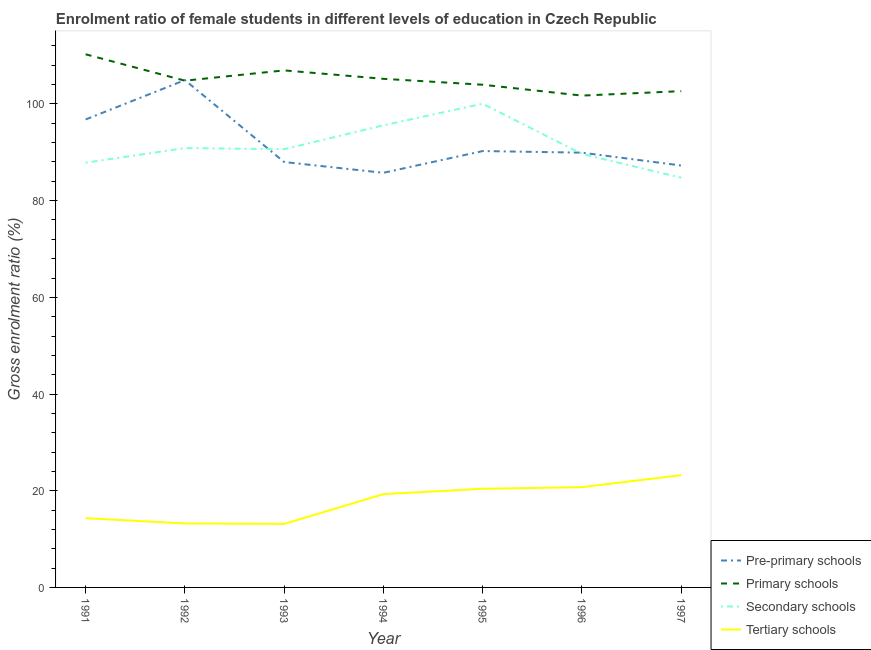How many different coloured lines are there?
Provide a short and direct response. 4. Does the line corresponding to gross enrolment ratio(male) in pre-primary schools intersect with the line corresponding to gross enrolment ratio(male) in tertiary schools?
Provide a succinct answer. No. What is the gross enrolment ratio(male) in primary schools in 1996?
Ensure brevity in your answer.  101.73. Across all years, what is the maximum gross enrolment ratio(male) in pre-primary schools?
Provide a short and direct response. 104.93. Across all years, what is the minimum gross enrolment ratio(male) in secondary schools?
Your answer should be very brief. 84.74. In which year was the gross enrolment ratio(male) in primary schools maximum?
Your answer should be very brief. 1991. What is the total gross enrolment ratio(male) in secondary schools in the graph?
Your answer should be compact. 639.41. What is the difference between the gross enrolment ratio(male) in tertiary schools in 1992 and that in 1993?
Give a very brief answer. 0.1. What is the difference between the gross enrolment ratio(male) in tertiary schools in 1993 and the gross enrolment ratio(male) in primary schools in 1997?
Give a very brief answer. -89.51. What is the average gross enrolment ratio(male) in pre-primary schools per year?
Give a very brief answer. 91.85. In the year 1997, what is the difference between the gross enrolment ratio(male) in primary schools and gross enrolment ratio(male) in tertiary schools?
Offer a very short reply. 79.44. In how many years, is the gross enrolment ratio(male) in primary schools greater than 4 %?
Ensure brevity in your answer.  7. What is the ratio of the gross enrolment ratio(male) in secondary schools in 1991 to that in 1994?
Provide a succinct answer. 0.92. Is the gross enrolment ratio(male) in secondary schools in 1991 less than that in 1997?
Your response must be concise. No. Is the difference between the gross enrolment ratio(male) in primary schools in 1992 and 1994 greater than the difference between the gross enrolment ratio(male) in pre-primary schools in 1992 and 1994?
Your answer should be compact. No. What is the difference between the highest and the second highest gross enrolment ratio(male) in tertiary schools?
Keep it short and to the point. 2.47. What is the difference between the highest and the lowest gross enrolment ratio(male) in primary schools?
Offer a very short reply. 8.54. In how many years, is the gross enrolment ratio(male) in tertiary schools greater than the average gross enrolment ratio(male) in tertiary schools taken over all years?
Give a very brief answer. 4. Is the sum of the gross enrolment ratio(male) in tertiary schools in 1992 and 1994 greater than the maximum gross enrolment ratio(male) in pre-primary schools across all years?
Provide a short and direct response. No. Is it the case that in every year, the sum of the gross enrolment ratio(male) in pre-primary schools and gross enrolment ratio(male) in primary schools is greater than the sum of gross enrolment ratio(male) in secondary schools and gross enrolment ratio(male) in tertiary schools?
Your answer should be compact. No. Is it the case that in every year, the sum of the gross enrolment ratio(male) in pre-primary schools and gross enrolment ratio(male) in primary schools is greater than the gross enrolment ratio(male) in secondary schools?
Offer a very short reply. Yes. Is the gross enrolment ratio(male) in pre-primary schools strictly greater than the gross enrolment ratio(male) in primary schools over the years?
Keep it short and to the point. No. Is the gross enrolment ratio(male) in primary schools strictly less than the gross enrolment ratio(male) in pre-primary schools over the years?
Provide a short and direct response. No. How many years are there in the graph?
Keep it short and to the point. 7. What is the difference between two consecutive major ticks on the Y-axis?
Provide a short and direct response. 20. Are the values on the major ticks of Y-axis written in scientific E-notation?
Give a very brief answer. No. Does the graph contain any zero values?
Your answer should be very brief. No. Does the graph contain grids?
Offer a very short reply. No. Where does the legend appear in the graph?
Make the answer very short. Bottom right. How are the legend labels stacked?
Your answer should be compact. Vertical. What is the title of the graph?
Provide a short and direct response. Enrolment ratio of female students in different levels of education in Czech Republic. Does "Gender equality" appear as one of the legend labels in the graph?
Ensure brevity in your answer.  No. What is the label or title of the X-axis?
Offer a very short reply. Year. What is the label or title of the Y-axis?
Your answer should be compact. Gross enrolment ratio (%). What is the Gross enrolment ratio (%) in Pre-primary schools in 1991?
Provide a short and direct response. 96.79. What is the Gross enrolment ratio (%) of Primary schools in 1991?
Ensure brevity in your answer.  110.27. What is the Gross enrolment ratio (%) of Secondary schools in 1991?
Offer a very short reply. 87.86. What is the Gross enrolment ratio (%) of Tertiary schools in 1991?
Your answer should be compact. 14.32. What is the Gross enrolment ratio (%) of Pre-primary schools in 1992?
Provide a succinct answer. 104.93. What is the Gross enrolment ratio (%) of Primary schools in 1992?
Ensure brevity in your answer.  104.82. What is the Gross enrolment ratio (%) of Secondary schools in 1992?
Offer a very short reply. 90.87. What is the Gross enrolment ratio (%) of Tertiary schools in 1992?
Your answer should be compact. 13.24. What is the Gross enrolment ratio (%) in Pre-primary schools in 1993?
Keep it short and to the point. 87.99. What is the Gross enrolment ratio (%) of Primary schools in 1993?
Your response must be concise. 106.94. What is the Gross enrolment ratio (%) in Secondary schools in 1993?
Offer a very short reply. 90.64. What is the Gross enrolment ratio (%) in Tertiary schools in 1993?
Give a very brief answer. 13.14. What is the Gross enrolment ratio (%) in Pre-primary schools in 1994?
Make the answer very short. 85.76. What is the Gross enrolment ratio (%) of Primary schools in 1994?
Keep it short and to the point. 105.2. What is the Gross enrolment ratio (%) in Secondary schools in 1994?
Give a very brief answer. 95.59. What is the Gross enrolment ratio (%) of Tertiary schools in 1994?
Your answer should be compact. 19.3. What is the Gross enrolment ratio (%) in Pre-primary schools in 1995?
Ensure brevity in your answer.  90.26. What is the Gross enrolment ratio (%) in Primary schools in 1995?
Give a very brief answer. 103.98. What is the Gross enrolment ratio (%) in Secondary schools in 1995?
Your response must be concise. 100.05. What is the Gross enrolment ratio (%) of Tertiary schools in 1995?
Give a very brief answer. 20.4. What is the Gross enrolment ratio (%) of Pre-primary schools in 1996?
Your response must be concise. 89.93. What is the Gross enrolment ratio (%) of Primary schools in 1996?
Your answer should be very brief. 101.73. What is the Gross enrolment ratio (%) in Secondary schools in 1996?
Your response must be concise. 89.66. What is the Gross enrolment ratio (%) of Tertiary schools in 1996?
Keep it short and to the point. 20.74. What is the Gross enrolment ratio (%) in Pre-primary schools in 1997?
Keep it short and to the point. 87.26. What is the Gross enrolment ratio (%) in Primary schools in 1997?
Provide a short and direct response. 102.65. What is the Gross enrolment ratio (%) in Secondary schools in 1997?
Your answer should be very brief. 84.74. What is the Gross enrolment ratio (%) of Tertiary schools in 1997?
Your response must be concise. 23.22. Across all years, what is the maximum Gross enrolment ratio (%) of Pre-primary schools?
Provide a short and direct response. 104.93. Across all years, what is the maximum Gross enrolment ratio (%) in Primary schools?
Your answer should be compact. 110.27. Across all years, what is the maximum Gross enrolment ratio (%) in Secondary schools?
Offer a very short reply. 100.05. Across all years, what is the maximum Gross enrolment ratio (%) of Tertiary schools?
Provide a short and direct response. 23.22. Across all years, what is the minimum Gross enrolment ratio (%) in Pre-primary schools?
Your answer should be very brief. 85.76. Across all years, what is the minimum Gross enrolment ratio (%) of Primary schools?
Ensure brevity in your answer.  101.73. Across all years, what is the minimum Gross enrolment ratio (%) in Secondary schools?
Offer a terse response. 84.74. Across all years, what is the minimum Gross enrolment ratio (%) in Tertiary schools?
Make the answer very short. 13.14. What is the total Gross enrolment ratio (%) of Pre-primary schools in the graph?
Your answer should be compact. 642.93. What is the total Gross enrolment ratio (%) in Primary schools in the graph?
Provide a short and direct response. 735.59. What is the total Gross enrolment ratio (%) in Secondary schools in the graph?
Keep it short and to the point. 639.41. What is the total Gross enrolment ratio (%) of Tertiary schools in the graph?
Ensure brevity in your answer.  124.35. What is the difference between the Gross enrolment ratio (%) in Pre-primary schools in 1991 and that in 1992?
Your answer should be very brief. -8.14. What is the difference between the Gross enrolment ratio (%) of Primary schools in 1991 and that in 1992?
Provide a short and direct response. 5.45. What is the difference between the Gross enrolment ratio (%) of Secondary schools in 1991 and that in 1992?
Offer a very short reply. -3.02. What is the difference between the Gross enrolment ratio (%) of Tertiary schools in 1991 and that in 1992?
Make the answer very short. 1.08. What is the difference between the Gross enrolment ratio (%) in Pre-primary schools in 1991 and that in 1993?
Offer a very short reply. 8.81. What is the difference between the Gross enrolment ratio (%) of Primary schools in 1991 and that in 1993?
Make the answer very short. 3.33. What is the difference between the Gross enrolment ratio (%) of Secondary schools in 1991 and that in 1993?
Offer a terse response. -2.79. What is the difference between the Gross enrolment ratio (%) of Tertiary schools in 1991 and that in 1993?
Offer a very short reply. 1.18. What is the difference between the Gross enrolment ratio (%) in Pre-primary schools in 1991 and that in 1994?
Your response must be concise. 11.03. What is the difference between the Gross enrolment ratio (%) of Primary schools in 1991 and that in 1994?
Ensure brevity in your answer.  5.07. What is the difference between the Gross enrolment ratio (%) in Secondary schools in 1991 and that in 1994?
Provide a succinct answer. -7.73. What is the difference between the Gross enrolment ratio (%) in Tertiary schools in 1991 and that in 1994?
Offer a very short reply. -4.98. What is the difference between the Gross enrolment ratio (%) in Pre-primary schools in 1991 and that in 1995?
Keep it short and to the point. 6.53. What is the difference between the Gross enrolment ratio (%) in Primary schools in 1991 and that in 1995?
Provide a short and direct response. 6.3. What is the difference between the Gross enrolment ratio (%) in Secondary schools in 1991 and that in 1995?
Your answer should be compact. -12.19. What is the difference between the Gross enrolment ratio (%) of Tertiary schools in 1991 and that in 1995?
Make the answer very short. -6.08. What is the difference between the Gross enrolment ratio (%) of Pre-primary schools in 1991 and that in 1996?
Your answer should be very brief. 6.87. What is the difference between the Gross enrolment ratio (%) in Primary schools in 1991 and that in 1996?
Your response must be concise. 8.54. What is the difference between the Gross enrolment ratio (%) in Secondary schools in 1991 and that in 1996?
Ensure brevity in your answer.  -1.81. What is the difference between the Gross enrolment ratio (%) of Tertiary schools in 1991 and that in 1996?
Ensure brevity in your answer.  -6.42. What is the difference between the Gross enrolment ratio (%) in Pre-primary schools in 1991 and that in 1997?
Provide a succinct answer. 9.53. What is the difference between the Gross enrolment ratio (%) of Primary schools in 1991 and that in 1997?
Make the answer very short. 7.62. What is the difference between the Gross enrolment ratio (%) in Secondary schools in 1991 and that in 1997?
Make the answer very short. 3.11. What is the difference between the Gross enrolment ratio (%) in Tertiary schools in 1991 and that in 1997?
Make the answer very short. -8.9. What is the difference between the Gross enrolment ratio (%) in Pre-primary schools in 1992 and that in 1993?
Keep it short and to the point. 16.95. What is the difference between the Gross enrolment ratio (%) of Primary schools in 1992 and that in 1993?
Give a very brief answer. -2.13. What is the difference between the Gross enrolment ratio (%) of Secondary schools in 1992 and that in 1993?
Offer a very short reply. 0.23. What is the difference between the Gross enrolment ratio (%) in Tertiary schools in 1992 and that in 1993?
Your answer should be very brief. 0.1. What is the difference between the Gross enrolment ratio (%) of Pre-primary schools in 1992 and that in 1994?
Ensure brevity in your answer.  19.17. What is the difference between the Gross enrolment ratio (%) in Primary schools in 1992 and that in 1994?
Ensure brevity in your answer.  -0.38. What is the difference between the Gross enrolment ratio (%) of Secondary schools in 1992 and that in 1994?
Your response must be concise. -4.71. What is the difference between the Gross enrolment ratio (%) in Tertiary schools in 1992 and that in 1994?
Ensure brevity in your answer.  -6.06. What is the difference between the Gross enrolment ratio (%) in Pre-primary schools in 1992 and that in 1995?
Offer a very short reply. 14.67. What is the difference between the Gross enrolment ratio (%) in Primary schools in 1992 and that in 1995?
Keep it short and to the point. 0.84. What is the difference between the Gross enrolment ratio (%) of Secondary schools in 1992 and that in 1995?
Provide a succinct answer. -9.18. What is the difference between the Gross enrolment ratio (%) of Tertiary schools in 1992 and that in 1995?
Offer a very short reply. -7.17. What is the difference between the Gross enrolment ratio (%) in Pre-primary schools in 1992 and that in 1996?
Offer a very short reply. 15.01. What is the difference between the Gross enrolment ratio (%) in Primary schools in 1992 and that in 1996?
Make the answer very short. 3.09. What is the difference between the Gross enrolment ratio (%) in Secondary schools in 1992 and that in 1996?
Give a very brief answer. 1.21. What is the difference between the Gross enrolment ratio (%) in Tertiary schools in 1992 and that in 1996?
Make the answer very short. -7.51. What is the difference between the Gross enrolment ratio (%) in Pre-primary schools in 1992 and that in 1997?
Keep it short and to the point. 17.67. What is the difference between the Gross enrolment ratio (%) of Primary schools in 1992 and that in 1997?
Your answer should be compact. 2.16. What is the difference between the Gross enrolment ratio (%) of Secondary schools in 1992 and that in 1997?
Keep it short and to the point. 6.13. What is the difference between the Gross enrolment ratio (%) in Tertiary schools in 1992 and that in 1997?
Your answer should be compact. -9.98. What is the difference between the Gross enrolment ratio (%) in Pre-primary schools in 1993 and that in 1994?
Ensure brevity in your answer.  2.22. What is the difference between the Gross enrolment ratio (%) of Primary schools in 1993 and that in 1994?
Make the answer very short. 1.74. What is the difference between the Gross enrolment ratio (%) of Secondary schools in 1993 and that in 1994?
Your answer should be compact. -4.95. What is the difference between the Gross enrolment ratio (%) of Tertiary schools in 1993 and that in 1994?
Your answer should be compact. -6.16. What is the difference between the Gross enrolment ratio (%) in Pre-primary schools in 1993 and that in 1995?
Your response must be concise. -2.27. What is the difference between the Gross enrolment ratio (%) in Primary schools in 1993 and that in 1995?
Your answer should be very brief. 2.97. What is the difference between the Gross enrolment ratio (%) in Secondary schools in 1993 and that in 1995?
Your answer should be very brief. -9.41. What is the difference between the Gross enrolment ratio (%) of Tertiary schools in 1993 and that in 1995?
Make the answer very short. -7.26. What is the difference between the Gross enrolment ratio (%) in Pre-primary schools in 1993 and that in 1996?
Ensure brevity in your answer.  -1.94. What is the difference between the Gross enrolment ratio (%) of Primary schools in 1993 and that in 1996?
Ensure brevity in your answer.  5.21. What is the difference between the Gross enrolment ratio (%) of Secondary schools in 1993 and that in 1996?
Ensure brevity in your answer.  0.98. What is the difference between the Gross enrolment ratio (%) of Tertiary schools in 1993 and that in 1996?
Offer a very short reply. -7.6. What is the difference between the Gross enrolment ratio (%) of Pre-primary schools in 1993 and that in 1997?
Your response must be concise. 0.72. What is the difference between the Gross enrolment ratio (%) of Primary schools in 1993 and that in 1997?
Provide a short and direct response. 4.29. What is the difference between the Gross enrolment ratio (%) in Secondary schools in 1993 and that in 1997?
Give a very brief answer. 5.9. What is the difference between the Gross enrolment ratio (%) in Tertiary schools in 1993 and that in 1997?
Ensure brevity in your answer.  -10.08. What is the difference between the Gross enrolment ratio (%) of Pre-primary schools in 1994 and that in 1995?
Provide a short and direct response. -4.5. What is the difference between the Gross enrolment ratio (%) of Primary schools in 1994 and that in 1995?
Provide a short and direct response. 1.22. What is the difference between the Gross enrolment ratio (%) of Secondary schools in 1994 and that in 1995?
Provide a succinct answer. -4.46. What is the difference between the Gross enrolment ratio (%) in Tertiary schools in 1994 and that in 1995?
Your answer should be compact. -1.1. What is the difference between the Gross enrolment ratio (%) in Pre-primary schools in 1994 and that in 1996?
Offer a terse response. -4.16. What is the difference between the Gross enrolment ratio (%) of Primary schools in 1994 and that in 1996?
Your response must be concise. 3.47. What is the difference between the Gross enrolment ratio (%) of Secondary schools in 1994 and that in 1996?
Your answer should be compact. 5.93. What is the difference between the Gross enrolment ratio (%) in Tertiary schools in 1994 and that in 1996?
Offer a very short reply. -1.44. What is the difference between the Gross enrolment ratio (%) in Pre-primary schools in 1994 and that in 1997?
Your answer should be very brief. -1.5. What is the difference between the Gross enrolment ratio (%) of Primary schools in 1994 and that in 1997?
Make the answer very short. 2.55. What is the difference between the Gross enrolment ratio (%) in Secondary schools in 1994 and that in 1997?
Ensure brevity in your answer.  10.84. What is the difference between the Gross enrolment ratio (%) of Tertiary schools in 1994 and that in 1997?
Provide a short and direct response. -3.92. What is the difference between the Gross enrolment ratio (%) in Pre-primary schools in 1995 and that in 1996?
Provide a succinct answer. 0.33. What is the difference between the Gross enrolment ratio (%) of Primary schools in 1995 and that in 1996?
Your answer should be compact. 2.25. What is the difference between the Gross enrolment ratio (%) of Secondary schools in 1995 and that in 1996?
Keep it short and to the point. 10.39. What is the difference between the Gross enrolment ratio (%) of Tertiary schools in 1995 and that in 1996?
Your answer should be compact. -0.34. What is the difference between the Gross enrolment ratio (%) of Pre-primary schools in 1995 and that in 1997?
Ensure brevity in your answer.  3. What is the difference between the Gross enrolment ratio (%) in Primary schools in 1995 and that in 1997?
Provide a short and direct response. 1.32. What is the difference between the Gross enrolment ratio (%) in Secondary schools in 1995 and that in 1997?
Your response must be concise. 15.3. What is the difference between the Gross enrolment ratio (%) of Tertiary schools in 1995 and that in 1997?
Your response must be concise. -2.81. What is the difference between the Gross enrolment ratio (%) of Pre-primary schools in 1996 and that in 1997?
Offer a terse response. 2.66. What is the difference between the Gross enrolment ratio (%) of Primary schools in 1996 and that in 1997?
Your response must be concise. -0.92. What is the difference between the Gross enrolment ratio (%) of Secondary schools in 1996 and that in 1997?
Make the answer very short. 4.92. What is the difference between the Gross enrolment ratio (%) of Tertiary schools in 1996 and that in 1997?
Your response must be concise. -2.47. What is the difference between the Gross enrolment ratio (%) in Pre-primary schools in 1991 and the Gross enrolment ratio (%) in Primary schools in 1992?
Offer a terse response. -8.02. What is the difference between the Gross enrolment ratio (%) of Pre-primary schools in 1991 and the Gross enrolment ratio (%) of Secondary schools in 1992?
Ensure brevity in your answer.  5.92. What is the difference between the Gross enrolment ratio (%) in Pre-primary schools in 1991 and the Gross enrolment ratio (%) in Tertiary schools in 1992?
Your answer should be very brief. 83.56. What is the difference between the Gross enrolment ratio (%) of Primary schools in 1991 and the Gross enrolment ratio (%) of Secondary schools in 1992?
Offer a terse response. 19.4. What is the difference between the Gross enrolment ratio (%) in Primary schools in 1991 and the Gross enrolment ratio (%) in Tertiary schools in 1992?
Make the answer very short. 97.03. What is the difference between the Gross enrolment ratio (%) of Secondary schools in 1991 and the Gross enrolment ratio (%) of Tertiary schools in 1992?
Provide a short and direct response. 74.62. What is the difference between the Gross enrolment ratio (%) in Pre-primary schools in 1991 and the Gross enrolment ratio (%) in Primary schools in 1993?
Make the answer very short. -10.15. What is the difference between the Gross enrolment ratio (%) of Pre-primary schools in 1991 and the Gross enrolment ratio (%) of Secondary schools in 1993?
Provide a short and direct response. 6.15. What is the difference between the Gross enrolment ratio (%) of Pre-primary schools in 1991 and the Gross enrolment ratio (%) of Tertiary schools in 1993?
Your answer should be compact. 83.65. What is the difference between the Gross enrolment ratio (%) of Primary schools in 1991 and the Gross enrolment ratio (%) of Secondary schools in 1993?
Keep it short and to the point. 19.63. What is the difference between the Gross enrolment ratio (%) of Primary schools in 1991 and the Gross enrolment ratio (%) of Tertiary schools in 1993?
Offer a terse response. 97.13. What is the difference between the Gross enrolment ratio (%) of Secondary schools in 1991 and the Gross enrolment ratio (%) of Tertiary schools in 1993?
Make the answer very short. 74.72. What is the difference between the Gross enrolment ratio (%) of Pre-primary schools in 1991 and the Gross enrolment ratio (%) of Primary schools in 1994?
Ensure brevity in your answer.  -8.41. What is the difference between the Gross enrolment ratio (%) of Pre-primary schools in 1991 and the Gross enrolment ratio (%) of Secondary schools in 1994?
Offer a terse response. 1.21. What is the difference between the Gross enrolment ratio (%) of Pre-primary schools in 1991 and the Gross enrolment ratio (%) of Tertiary schools in 1994?
Ensure brevity in your answer.  77.5. What is the difference between the Gross enrolment ratio (%) in Primary schools in 1991 and the Gross enrolment ratio (%) in Secondary schools in 1994?
Keep it short and to the point. 14.68. What is the difference between the Gross enrolment ratio (%) in Primary schools in 1991 and the Gross enrolment ratio (%) in Tertiary schools in 1994?
Keep it short and to the point. 90.97. What is the difference between the Gross enrolment ratio (%) of Secondary schools in 1991 and the Gross enrolment ratio (%) of Tertiary schools in 1994?
Give a very brief answer. 68.56. What is the difference between the Gross enrolment ratio (%) of Pre-primary schools in 1991 and the Gross enrolment ratio (%) of Primary schools in 1995?
Ensure brevity in your answer.  -7.18. What is the difference between the Gross enrolment ratio (%) in Pre-primary schools in 1991 and the Gross enrolment ratio (%) in Secondary schools in 1995?
Ensure brevity in your answer.  -3.26. What is the difference between the Gross enrolment ratio (%) in Pre-primary schools in 1991 and the Gross enrolment ratio (%) in Tertiary schools in 1995?
Give a very brief answer. 76.39. What is the difference between the Gross enrolment ratio (%) in Primary schools in 1991 and the Gross enrolment ratio (%) in Secondary schools in 1995?
Your response must be concise. 10.22. What is the difference between the Gross enrolment ratio (%) in Primary schools in 1991 and the Gross enrolment ratio (%) in Tertiary schools in 1995?
Make the answer very short. 89.87. What is the difference between the Gross enrolment ratio (%) of Secondary schools in 1991 and the Gross enrolment ratio (%) of Tertiary schools in 1995?
Make the answer very short. 67.45. What is the difference between the Gross enrolment ratio (%) in Pre-primary schools in 1991 and the Gross enrolment ratio (%) in Primary schools in 1996?
Provide a succinct answer. -4.94. What is the difference between the Gross enrolment ratio (%) in Pre-primary schools in 1991 and the Gross enrolment ratio (%) in Secondary schools in 1996?
Provide a succinct answer. 7.13. What is the difference between the Gross enrolment ratio (%) in Pre-primary schools in 1991 and the Gross enrolment ratio (%) in Tertiary schools in 1996?
Make the answer very short. 76.05. What is the difference between the Gross enrolment ratio (%) of Primary schools in 1991 and the Gross enrolment ratio (%) of Secondary schools in 1996?
Ensure brevity in your answer.  20.61. What is the difference between the Gross enrolment ratio (%) in Primary schools in 1991 and the Gross enrolment ratio (%) in Tertiary schools in 1996?
Make the answer very short. 89.53. What is the difference between the Gross enrolment ratio (%) of Secondary schools in 1991 and the Gross enrolment ratio (%) of Tertiary schools in 1996?
Your response must be concise. 67.11. What is the difference between the Gross enrolment ratio (%) of Pre-primary schools in 1991 and the Gross enrolment ratio (%) of Primary schools in 1997?
Your response must be concise. -5.86. What is the difference between the Gross enrolment ratio (%) in Pre-primary schools in 1991 and the Gross enrolment ratio (%) in Secondary schools in 1997?
Ensure brevity in your answer.  12.05. What is the difference between the Gross enrolment ratio (%) in Pre-primary schools in 1991 and the Gross enrolment ratio (%) in Tertiary schools in 1997?
Offer a very short reply. 73.58. What is the difference between the Gross enrolment ratio (%) of Primary schools in 1991 and the Gross enrolment ratio (%) of Secondary schools in 1997?
Give a very brief answer. 25.53. What is the difference between the Gross enrolment ratio (%) in Primary schools in 1991 and the Gross enrolment ratio (%) in Tertiary schools in 1997?
Give a very brief answer. 87.06. What is the difference between the Gross enrolment ratio (%) in Secondary schools in 1991 and the Gross enrolment ratio (%) in Tertiary schools in 1997?
Your answer should be compact. 64.64. What is the difference between the Gross enrolment ratio (%) in Pre-primary schools in 1992 and the Gross enrolment ratio (%) in Primary schools in 1993?
Your answer should be compact. -2.01. What is the difference between the Gross enrolment ratio (%) in Pre-primary schools in 1992 and the Gross enrolment ratio (%) in Secondary schools in 1993?
Give a very brief answer. 14.29. What is the difference between the Gross enrolment ratio (%) of Pre-primary schools in 1992 and the Gross enrolment ratio (%) of Tertiary schools in 1993?
Your response must be concise. 91.79. What is the difference between the Gross enrolment ratio (%) in Primary schools in 1992 and the Gross enrolment ratio (%) in Secondary schools in 1993?
Offer a terse response. 14.18. What is the difference between the Gross enrolment ratio (%) of Primary schools in 1992 and the Gross enrolment ratio (%) of Tertiary schools in 1993?
Keep it short and to the point. 91.68. What is the difference between the Gross enrolment ratio (%) of Secondary schools in 1992 and the Gross enrolment ratio (%) of Tertiary schools in 1993?
Provide a succinct answer. 77.73. What is the difference between the Gross enrolment ratio (%) of Pre-primary schools in 1992 and the Gross enrolment ratio (%) of Primary schools in 1994?
Make the answer very short. -0.27. What is the difference between the Gross enrolment ratio (%) of Pre-primary schools in 1992 and the Gross enrolment ratio (%) of Secondary schools in 1994?
Offer a very short reply. 9.35. What is the difference between the Gross enrolment ratio (%) of Pre-primary schools in 1992 and the Gross enrolment ratio (%) of Tertiary schools in 1994?
Offer a terse response. 85.64. What is the difference between the Gross enrolment ratio (%) of Primary schools in 1992 and the Gross enrolment ratio (%) of Secondary schools in 1994?
Make the answer very short. 9.23. What is the difference between the Gross enrolment ratio (%) in Primary schools in 1992 and the Gross enrolment ratio (%) in Tertiary schools in 1994?
Make the answer very short. 85.52. What is the difference between the Gross enrolment ratio (%) of Secondary schools in 1992 and the Gross enrolment ratio (%) of Tertiary schools in 1994?
Make the answer very short. 71.58. What is the difference between the Gross enrolment ratio (%) in Pre-primary schools in 1992 and the Gross enrolment ratio (%) in Primary schools in 1995?
Offer a very short reply. 0.96. What is the difference between the Gross enrolment ratio (%) of Pre-primary schools in 1992 and the Gross enrolment ratio (%) of Secondary schools in 1995?
Keep it short and to the point. 4.88. What is the difference between the Gross enrolment ratio (%) in Pre-primary schools in 1992 and the Gross enrolment ratio (%) in Tertiary schools in 1995?
Provide a short and direct response. 84.53. What is the difference between the Gross enrolment ratio (%) in Primary schools in 1992 and the Gross enrolment ratio (%) in Secondary schools in 1995?
Your answer should be compact. 4.77. What is the difference between the Gross enrolment ratio (%) of Primary schools in 1992 and the Gross enrolment ratio (%) of Tertiary schools in 1995?
Make the answer very short. 84.42. What is the difference between the Gross enrolment ratio (%) in Secondary schools in 1992 and the Gross enrolment ratio (%) in Tertiary schools in 1995?
Your answer should be compact. 70.47. What is the difference between the Gross enrolment ratio (%) of Pre-primary schools in 1992 and the Gross enrolment ratio (%) of Primary schools in 1996?
Make the answer very short. 3.2. What is the difference between the Gross enrolment ratio (%) of Pre-primary schools in 1992 and the Gross enrolment ratio (%) of Secondary schools in 1996?
Offer a terse response. 15.27. What is the difference between the Gross enrolment ratio (%) of Pre-primary schools in 1992 and the Gross enrolment ratio (%) of Tertiary schools in 1996?
Provide a succinct answer. 84.19. What is the difference between the Gross enrolment ratio (%) of Primary schools in 1992 and the Gross enrolment ratio (%) of Secondary schools in 1996?
Provide a succinct answer. 15.16. What is the difference between the Gross enrolment ratio (%) of Primary schools in 1992 and the Gross enrolment ratio (%) of Tertiary schools in 1996?
Give a very brief answer. 84.07. What is the difference between the Gross enrolment ratio (%) in Secondary schools in 1992 and the Gross enrolment ratio (%) in Tertiary schools in 1996?
Offer a very short reply. 70.13. What is the difference between the Gross enrolment ratio (%) in Pre-primary schools in 1992 and the Gross enrolment ratio (%) in Primary schools in 1997?
Provide a short and direct response. 2.28. What is the difference between the Gross enrolment ratio (%) of Pre-primary schools in 1992 and the Gross enrolment ratio (%) of Secondary schools in 1997?
Provide a succinct answer. 20.19. What is the difference between the Gross enrolment ratio (%) in Pre-primary schools in 1992 and the Gross enrolment ratio (%) in Tertiary schools in 1997?
Provide a short and direct response. 81.72. What is the difference between the Gross enrolment ratio (%) of Primary schools in 1992 and the Gross enrolment ratio (%) of Secondary schools in 1997?
Offer a very short reply. 20.07. What is the difference between the Gross enrolment ratio (%) of Primary schools in 1992 and the Gross enrolment ratio (%) of Tertiary schools in 1997?
Offer a terse response. 81.6. What is the difference between the Gross enrolment ratio (%) in Secondary schools in 1992 and the Gross enrolment ratio (%) in Tertiary schools in 1997?
Keep it short and to the point. 67.66. What is the difference between the Gross enrolment ratio (%) in Pre-primary schools in 1993 and the Gross enrolment ratio (%) in Primary schools in 1994?
Offer a very short reply. -17.21. What is the difference between the Gross enrolment ratio (%) in Pre-primary schools in 1993 and the Gross enrolment ratio (%) in Secondary schools in 1994?
Provide a succinct answer. -7.6. What is the difference between the Gross enrolment ratio (%) of Pre-primary schools in 1993 and the Gross enrolment ratio (%) of Tertiary schools in 1994?
Your answer should be compact. 68.69. What is the difference between the Gross enrolment ratio (%) of Primary schools in 1993 and the Gross enrolment ratio (%) of Secondary schools in 1994?
Make the answer very short. 11.36. What is the difference between the Gross enrolment ratio (%) of Primary schools in 1993 and the Gross enrolment ratio (%) of Tertiary schools in 1994?
Provide a succinct answer. 87.65. What is the difference between the Gross enrolment ratio (%) in Secondary schools in 1993 and the Gross enrolment ratio (%) in Tertiary schools in 1994?
Your answer should be very brief. 71.34. What is the difference between the Gross enrolment ratio (%) of Pre-primary schools in 1993 and the Gross enrolment ratio (%) of Primary schools in 1995?
Your answer should be very brief. -15.99. What is the difference between the Gross enrolment ratio (%) in Pre-primary schools in 1993 and the Gross enrolment ratio (%) in Secondary schools in 1995?
Provide a succinct answer. -12.06. What is the difference between the Gross enrolment ratio (%) in Pre-primary schools in 1993 and the Gross enrolment ratio (%) in Tertiary schools in 1995?
Offer a very short reply. 67.59. What is the difference between the Gross enrolment ratio (%) in Primary schools in 1993 and the Gross enrolment ratio (%) in Secondary schools in 1995?
Offer a terse response. 6.9. What is the difference between the Gross enrolment ratio (%) in Primary schools in 1993 and the Gross enrolment ratio (%) in Tertiary schools in 1995?
Your response must be concise. 86.54. What is the difference between the Gross enrolment ratio (%) of Secondary schools in 1993 and the Gross enrolment ratio (%) of Tertiary schools in 1995?
Offer a very short reply. 70.24. What is the difference between the Gross enrolment ratio (%) of Pre-primary schools in 1993 and the Gross enrolment ratio (%) of Primary schools in 1996?
Your response must be concise. -13.74. What is the difference between the Gross enrolment ratio (%) in Pre-primary schools in 1993 and the Gross enrolment ratio (%) in Secondary schools in 1996?
Provide a succinct answer. -1.67. What is the difference between the Gross enrolment ratio (%) in Pre-primary schools in 1993 and the Gross enrolment ratio (%) in Tertiary schools in 1996?
Give a very brief answer. 67.25. What is the difference between the Gross enrolment ratio (%) of Primary schools in 1993 and the Gross enrolment ratio (%) of Secondary schools in 1996?
Provide a short and direct response. 17.28. What is the difference between the Gross enrolment ratio (%) of Primary schools in 1993 and the Gross enrolment ratio (%) of Tertiary schools in 1996?
Provide a succinct answer. 86.2. What is the difference between the Gross enrolment ratio (%) of Secondary schools in 1993 and the Gross enrolment ratio (%) of Tertiary schools in 1996?
Offer a very short reply. 69.9. What is the difference between the Gross enrolment ratio (%) in Pre-primary schools in 1993 and the Gross enrolment ratio (%) in Primary schools in 1997?
Make the answer very short. -14.66. What is the difference between the Gross enrolment ratio (%) in Pre-primary schools in 1993 and the Gross enrolment ratio (%) in Secondary schools in 1997?
Provide a succinct answer. 3.24. What is the difference between the Gross enrolment ratio (%) in Pre-primary schools in 1993 and the Gross enrolment ratio (%) in Tertiary schools in 1997?
Provide a short and direct response. 64.77. What is the difference between the Gross enrolment ratio (%) of Primary schools in 1993 and the Gross enrolment ratio (%) of Secondary schools in 1997?
Give a very brief answer. 22.2. What is the difference between the Gross enrolment ratio (%) in Primary schools in 1993 and the Gross enrolment ratio (%) in Tertiary schools in 1997?
Provide a succinct answer. 83.73. What is the difference between the Gross enrolment ratio (%) of Secondary schools in 1993 and the Gross enrolment ratio (%) of Tertiary schools in 1997?
Give a very brief answer. 67.42. What is the difference between the Gross enrolment ratio (%) in Pre-primary schools in 1994 and the Gross enrolment ratio (%) in Primary schools in 1995?
Keep it short and to the point. -18.21. What is the difference between the Gross enrolment ratio (%) of Pre-primary schools in 1994 and the Gross enrolment ratio (%) of Secondary schools in 1995?
Offer a very short reply. -14.29. What is the difference between the Gross enrolment ratio (%) in Pre-primary schools in 1994 and the Gross enrolment ratio (%) in Tertiary schools in 1995?
Offer a terse response. 65.36. What is the difference between the Gross enrolment ratio (%) of Primary schools in 1994 and the Gross enrolment ratio (%) of Secondary schools in 1995?
Provide a short and direct response. 5.15. What is the difference between the Gross enrolment ratio (%) of Primary schools in 1994 and the Gross enrolment ratio (%) of Tertiary schools in 1995?
Give a very brief answer. 84.8. What is the difference between the Gross enrolment ratio (%) of Secondary schools in 1994 and the Gross enrolment ratio (%) of Tertiary schools in 1995?
Provide a succinct answer. 75.19. What is the difference between the Gross enrolment ratio (%) in Pre-primary schools in 1994 and the Gross enrolment ratio (%) in Primary schools in 1996?
Provide a short and direct response. -15.97. What is the difference between the Gross enrolment ratio (%) in Pre-primary schools in 1994 and the Gross enrolment ratio (%) in Secondary schools in 1996?
Offer a very short reply. -3.9. What is the difference between the Gross enrolment ratio (%) of Pre-primary schools in 1994 and the Gross enrolment ratio (%) of Tertiary schools in 1996?
Give a very brief answer. 65.02. What is the difference between the Gross enrolment ratio (%) of Primary schools in 1994 and the Gross enrolment ratio (%) of Secondary schools in 1996?
Your answer should be very brief. 15.54. What is the difference between the Gross enrolment ratio (%) in Primary schools in 1994 and the Gross enrolment ratio (%) in Tertiary schools in 1996?
Make the answer very short. 84.46. What is the difference between the Gross enrolment ratio (%) in Secondary schools in 1994 and the Gross enrolment ratio (%) in Tertiary schools in 1996?
Provide a succinct answer. 74.85. What is the difference between the Gross enrolment ratio (%) of Pre-primary schools in 1994 and the Gross enrolment ratio (%) of Primary schools in 1997?
Your answer should be compact. -16.89. What is the difference between the Gross enrolment ratio (%) in Pre-primary schools in 1994 and the Gross enrolment ratio (%) in Secondary schools in 1997?
Your answer should be very brief. 1.02. What is the difference between the Gross enrolment ratio (%) in Pre-primary schools in 1994 and the Gross enrolment ratio (%) in Tertiary schools in 1997?
Give a very brief answer. 62.55. What is the difference between the Gross enrolment ratio (%) in Primary schools in 1994 and the Gross enrolment ratio (%) in Secondary schools in 1997?
Give a very brief answer. 20.46. What is the difference between the Gross enrolment ratio (%) of Primary schools in 1994 and the Gross enrolment ratio (%) of Tertiary schools in 1997?
Your response must be concise. 81.98. What is the difference between the Gross enrolment ratio (%) in Secondary schools in 1994 and the Gross enrolment ratio (%) in Tertiary schools in 1997?
Ensure brevity in your answer.  72.37. What is the difference between the Gross enrolment ratio (%) in Pre-primary schools in 1995 and the Gross enrolment ratio (%) in Primary schools in 1996?
Ensure brevity in your answer.  -11.47. What is the difference between the Gross enrolment ratio (%) in Pre-primary schools in 1995 and the Gross enrolment ratio (%) in Secondary schools in 1996?
Offer a very short reply. 0.6. What is the difference between the Gross enrolment ratio (%) of Pre-primary schools in 1995 and the Gross enrolment ratio (%) of Tertiary schools in 1996?
Offer a very short reply. 69.52. What is the difference between the Gross enrolment ratio (%) in Primary schools in 1995 and the Gross enrolment ratio (%) in Secondary schools in 1996?
Provide a succinct answer. 14.31. What is the difference between the Gross enrolment ratio (%) in Primary schools in 1995 and the Gross enrolment ratio (%) in Tertiary schools in 1996?
Provide a succinct answer. 83.23. What is the difference between the Gross enrolment ratio (%) in Secondary schools in 1995 and the Gross enrolment ratio (%) in Tertiary schools in 1996?
Your answer should be very brief. 79.31. What is the difference between the Gross enrolment ratio (%) in Pre-primary schools in 1995 and the Gross enrolment ratio (%) in Primary schools in 1997?
Your response must be concise. -12.39. What is the difference between the Gross enrolment ratio (%) in Pre-primary schools in 1995 and the Gross enrolment ratio (%) in Secondary schools in 1997?
Provide a short and direct response. 5.52. What is the difference between the Gross enrolment ratio (%) of Pre-primary schools in 1995 and the Gross enrolment ratio (%) of Tertiary schools in 1997?
Your answer should be very brief. 67.05. What is the difference between the Gross enrolment ratio (%) in Primary schools in 1995 and the Gross enrolment ratio (%) in Secondary schools in 1997?
Your response must be concise. 19.23. What is the difference between the Gross enrolment ratio (%) of Primary schools in 1995 and the Gross enrolment ratio (%) of Tertiary schools in 1997?
Give a very brief answer. 80.76. What is the difference between the Gross enrolment ratio (%) in Secondary schools in 1995 and the Gross enrolment ratio (%) in Tertiary schools in 1997?
Make the answer very short. 76.83. What is the difference between the Gross enrolment ratio (%) of Pre-primary schools in 1996 and the Gross enrolment ratio (%) of Primary schools in 1997?
Your answer should be compact. -12.73. What is the difference between the Gross enrolment ratio (%) in Pre-primary schools in 1996 and the Gross enrolment ratio (%) in Secondary schools in 1997?
Give a very brief answer. 5.18. What is the difference between the Gross enrolment ratio (%) in Pre-primary schools in 1996 and the Gross enrolment ratio (%) in Tertiary schools in 1997?
Your response must be concise. 66.71. What is the difference between the Gross enrolment ratio (%) of Primary schools in 1996 and the Gross enrolment ratio (%) of Secondary schools in 1997?
Provide a short and direct response. 16.98. What is the difference between the Gross enrolment ratio (%) of Primary schools in 1996 and the Gross enrolment ratio (%) of Tertiary schools in 1997?
Offer a very short reply. 78.51. What is the difference between the Gross enrolment ratio (%) in Secondary schools in 1996 and the Gross enrolment ratio (%) in Tertiary schools in 1997?
Offer a terse response. 66.45. What is the average Gross enrolment ratio (%) in Pre-primary schools per year?
Provide a short and direct response. 91.85. What is the average Gross enrolment ratio (%) of Primary schools per year?
Offer a very short reply. 105.08. What is the average Gross enrolment ratio (%) of Secondary schools per year?
Provide a short and direct response. 91.34. What is the average Gross enrolment ratio (%) of Tertiary schools per year?
Your answer should be very brief. 17.76. In the year 1991, what is the difference between the Gross enrolment ratio (%) in Pre-primary schools and Gross enrolment ratio (%) in Primary schools?
Offer a very short reply. -13.48. In the year 1991, what is the difference between the Gross enrolment ratio (%) of Pre-primary schools and Gross enrolment ratio (%) of Secondary schools?
Provide a short and direct response. 8.94. In the year 1991, what is the difference between the Gross enrolment ratio (%) of Pre-primary schools and Gross enrolment ratio (%) of Tertiary schools?
Give a very brief answer. 82.47. In the year 1991, what is the difference between the Gross enrolment ratio (%) of Primary schools and Gross enrolment ratio (%) of Secondary schools?
Your response must be concise. 22.42. In the year 1991, what is the difference between the Gross enrolment ratio (%) of Primary schools and Gross enrolment ratio (%) of Tertiary schools?
Offer a very short reply. 95.95. In the year 1991, what is the difference between the Gross enrolment ratio (%) in Secondary schools and Gross enrolment ratio (%) in Tertiary schools?
Provide a short and direct response. 73.53. In the year 1992, what is the difference between the Gross enrolment ratio (%) in Pre-primary schools and Gross enrolment ratio (%) in Primary schools?
Your answer should be very brief. 0.12. In the year 1992, what is the difference between the Gross enrolment ratio (%) in Pre-primary schools and Gross enrolment ratio (%) in Secondary schools?
Your response must be concise. 14.06. In the year 1992, what is the difference between the Gross enrolment ratio (%) in Pre-primary schools and Gross enrolment ratio (%) in Tertiary schools?
Make the answer very short. 91.7. In the year 1992, what is the difference between the Gross enrolment ratio (%) of Primary schools and Gross enrolment ratio (%) of Secondary schools?
Your answer should be compact. 13.94. In the year 1992, what is the difference between the Gross enrolment ratio (%) in Primary schools and Gross enrolment ratio (%) in Tertiary schools?
Your response must be concise. 91.58. In the year 1992, what is the difference between the Gross enrolment ratio (%) in Secondary schools and Gross enrolment ratio (%) in Tertiary schools?
Provide a short and direct response. 77.64. In the year 1993, what is the difference between the Gross enrolment ratio (%) of Pre-primary schools and Gross enrolment ratio (%) of Primary schools?
Your response must be concise. -18.96. In the year 1993, what is the difference between the Gross enrolment ratio (%) in Pre-primary schools and Gross enrolment ratio (%) in Secondary schools?
Your answer should be very brief. -2.65. In the year 1993, what is the difference between the Gross enrolment ratio (%) in Pre-primary schools and Gross enrolment ratio (%) in Tertiary schools?
Make the answer very short. 74.85. In the year 1993, what is the difference between the Gross enrolment ratio (%) of Primary schools and Gross enrolment ratio (%) of Secondary schools?
Offer a terse response. 16.3. In the year 1993, what is the difference between the Gross enrolment ratio (%) in Primary schools and Gross enrolment ratio (%) in Tertiary schools?
Your answer should be compact. 93.8. In the year 1993, what is the difference between the Gross enrolment ratio (%) in Secondary schools and Gross enrolment ratio (%) in Tertiary schools?
Give a very brief answer. 77.5. In the year 1994, what is the difference between the Gross enrolment ratio (%) in Pre-primary schools and Gross enrolment ratio (%) in Primary schools?
Provide a short and direct response. -19.44. In the year 1994, what is the difference between the Gross enrolment ratio (%) of Pre-primary schools and Gross enrolment ratio (%) of Secondary schools?
Make the answer very short. -9.82. In the year 1994, what is the difference between the Gross enrolment ratio (%) of Pre-primary schools and Gross enrolment ratio (%) of Tertiary schools?
Your answer should be compact. 66.47. In the year 1994, what is the difference between the Gross enrolment ratio (%) in Primary schools and Gross enrolment ratio (%) in Secondary schools?
Keep it short and to the point. 9.61. In the year 1994, what is the difference between the Gross enrolment ratio (%) of Primary schools and Gross enrolment ratio (%) of Tertiary schools?
Provide a short and direct response. 85.9. In the year 1994, what is the difference between the Gross enrolment ratio (%) of Secondary schools and Gross enrolment ratio (%) of Tertiary schools?
Provide a short and direct response. 76.29. In the year 1995, what is the difference between the Gross enrolment ratio (%) in Pre-primary schools and Gross enrolment ratio (%) in Primary schools?
Ensure brevity in your answer.  -13.71. In the year 1995, what is the difference between the Gross enrolment ratio (%) of Pre-primary schools and Gross enrolment ratio (%) of Secondary schools?
Ensure brevity in your answer.  -9.79. In the year 1995, what is the difference between the Gross enrolment ratio (%) of Pre-primary schools and Gross enrolment ratio (%) of Tertiary schools?
Give a very brief answer. 69.86. In the year 1995, what is the difference between the Gross enrolment ratio (%) in Primary schools and Gross enrolment ratio (%) in Secondary schools?
Your response must be concise. 3.93. In the year 1995, what is the difference between the Gross enrolment ratio (%) of Primary schools and Gross enrolment ratio (%) of Tertiary schools?
Provide a short and direct response. 83.57. In the year 1995, what is the difference between the Gross enrolment ratio (%) in Secondary schools and Gross enrolment ratio (%) in Tertiary schools?
Make the answer very short. 79.65. In the year 1996, what is the difference between the Gross enrolment ratio (%) in Pre-primary schools and Gross enrolment ratio (%) in Primary schools?
Keep it short and to the point. -11.8. In the year 1996, what is the difference between the Gross enrolment ratio (%) of Pre-primary schools and Gross enrolment ratio (%) of Secondary schools?
Ensure brevity in your answer.  0.27. In the year 1996, what is the difference between the Gross enrolment ratio (%) of Pre-primary schools and Gross enrolment ratio (%) of Tertiary schools?
Provide a succinct answer. 69.19. In the year 1996, what is the difference between the Gross enrolment ratio (%) of Primary schools and Gross enrolment ratio (%) of Secondary schools?
Offer a terse response. 12.07. In the year 1996, what is the difference between the Gross enrolment ratio (%) of Primary schools and Gross enrolment ratio (%) of Tertiary schools?
Give a very brief answer. 80.99. In the year 1996, what is the difference between the Gross enrolment ratio (%) in Secondary schools and Gross enrolment ratio (%) in Tertiary schools?
Give a very brief answer. 68.92. In the year 1997, what is the difference between the Gross enrolment ratio (%) in Pre-primary schools and Gross enrolment ratio (%) in Primary schools?
Make the answer very short. -15.39. In the year 1997, what is the difference between the Gross enrolment ratio (%) in Pre-primary schools and Gross enrolment ratio (%) in Secondary schools?
Ensure brevity in your answer.  2.52. In the year 1997, what is the difference between the Gross enrolment ratio (%) of Pre-primary schools and Gross enrolment ratio (%) of Tertiary schools?
Provide a short and direct response. 64.05. In the year 1997, what is the difference between the Gross enrolment ratio (%) in Primary schools and Gross enrolment ratio (%) in Secondary schools?
Your answer should be compact. 17.91. In the year 1997, what is the difference between the Gross enrolment ratio (%) in Primary schools and Gross enrolment ratio (%) in Tertiary schools?
Give a very brief answer. 79.44. In the year 1997, what is the difference between the Gross enrolment ratio (%) of Secondary schools and Gross enrolment ratio (%) of Tertiary schools?
Offer a terse response. 61.53. What is the ratio of the Gross enrolment ratio (%) in Pre-primary schools in 1991 to that in 1992?
Your response must be concise. 0.92. What is the ratio of the Gross enrolment ratio (%) of Primary schools in 1991 to that in 1992?
Offer a terse response. 1.05. What is the ratio of the Gross enrolment ratio (%) of Secondary schools in 1991 to that in 1992?
Keep it short and to the point. 0.97. What is the ratio of the Gross enrolment ratio (%) in Tertiary schools in 1991 to that in 1992?
Your answer should be very brief. 1.08. What is the ratio of the Gross enrolment ratio (%) in Pre-primary schools in 1991 to that in 1993?
Ensure brevity in your answer.  1.1. What is the ratio of the Gross enrolment ratio (%) of Primary schools in 1991 to that in 1993?
Provide a succinct answer. 1.03. What is the ratio of the Gross enrolment ratio (%) of Secondary schools in 1991 to that in 1993?
Provide a succinct answer. 0.97. What is the ratio of the Gross enrolment ratio (%) in Tertiary schools in 1991 to that in 1993?
Provide a short and direct response. 1.09. What is the ratio of the Gross enrolment ratio (%) of Pre-primary schools in 1991 to that in 1994?
Ensure brevity in your answer.  1.13. What is the ratio of the Gross enrolment ratio (%) of Primary schools in 1991 to that in 1994?
Make the answer very short. 1.05. What is the ratio of the Gross enrolment ratio (%) of Secondary schools in 1991 to that in 1994?
Offer a very short reply. 0.92. What is the ratio of the Gross enrolment ratio (%) of Tertiary schools in 1991 to that in 1994?
Ensure brevity in your answer.  0.74. What is the ratio of the Gross enrolment ratio (%) in Pre-primary schools in 1991 to that in 1995?
Offer a very short reply. 1.07. What is the ratio of the Gross enrolment ratio (%) in Primary schools in 1991 to that in 1995?
Your response must be concise. 1.06. What is the ratio of the Gross enrolment ratio (%) of Secondary schools in 1991 to that in 1995?
Keep it short and to the point. 0.88. What is the ratio of the Gross enrolment ratio (%) of Tertiary schools in 1991 to that in 1995?
Make the answer very short. 0.7. What is the ratio of the Gross enrolment ratio (%) of Pre-primary schools in 1991 to that in 1996?
Your response must be concise. 1.08. What is the ratio of the Gross enrolment ratio (%) of Primary schools in 1991 to that in 1996?
Ensure brevity in your answer.  1.08. What is the ratio of the Gross enrolment ratio (%) in Secondary schools in 1991 to that in 1996?
Your response must be concise. 0.98. What is the ratio of the Gross enrolment ratio (%) of Tertiary schools in 1991 to that in 1996?
Provide a short and direct response. 0.69. What is the ratio of the Gross enrolment ratio (%) of Pre-primary schools in 1991 to that in 1997?
Keep it short and to the point. 1.11. What is the ratio of the Gross enrolment ratio (%) of Primary schools in 1991 to that in 1997?
Make the answer very short. 1.07. What is the ratio of the Gross enrolment ratio (%) in Secondary schools in 1991 to that in 1997?
Keep it short and to the point. 1.04. What is the ratio of the Gross enrolment ratio (%) of Tertiary schools in 1991 to that in 1997?
Your answer should be very brief. 0.62. What is the ratio of the Gross enrolment ratio (%) of Pre-primary schools in 1992 to that in 1993?
Offer a terse response. 1.19. What is the ratio of the Gross enrolment ratio (%) of Primary schools in 1992 to that in 1993?
Provide a short and direct response. 0.98. What is the ratio of the Gross enrolment ratio (%) of Tertiary schools in 1992 to that in 1993?
Your response must be concise. 1.01. What is the ratio of the Gross enrolment ratio (%) in Pre-primary schools in 1992 to that in 1994?
Your answer should be very brief. 1.22. What is the ratio of the Gross enrolment ratio (%) in Secondary schools in 1992 to that in 1994?
Provide a succinct answer. 0.95. What is the ratio of the Gross enrolment ratio (%) of Tertiary schools in 1992 to that in 1994?
Give a very brief answer. 0.69. What is the ratio of the Gross enrolment ratio (%) in Pre-primary schools in 1992 to that in 1995?
Give a very brief answer. 1.16. What is the ratio of the Gross enrolment ratio (%) in Secondary schools in 1992 to that in 1995?
Provide a short and direct response. 0.91. What is the ratio of the Gross enrolment ratio (%) in Tertiary schools in 1992 to that in 1995?
Offer a terse response. 0.65. What is the ratio of the Gross enrolment ratio (%) of Pre-primary schools in 1992 to that in 1996?
Provide a succinct answer. 1.17. What is the ratio of the Gross enrolment ratio (%) of Primary schools in 1992 to that in 1996?
Offer a terse response. 1.03. What is the ratio of the Gross enrolment ratio (%) in Secondary schools in 1992 to that in 1996?
Offer a very short reply. 1.01. What is the ratio of the Gross enrolment ratio (%) of Tertiary schools in 1992 to that in 1996?
Offer a very short reply. 0.64. What is the ratio of the Gross enrolment ratio (%) in Pre-primary schools in 1992 to that in 1997?
Your answer should be very brief. 1.2. What is the ratio of the Gross enrolment ratio (%) in Primary schools in 1992 to that in 1997?
Make the answer very short. 1.02. What is the ratio of the Gross enrolment ratio (%) of Secondary schools in 1992 to that in 1997?
Give a very brief answer. 1.07. What is the ratio of the Gross enrolment ratio (%) in Tertiary schools in 1992 to that in 1997?
Offer a terse response. 0.57. What is the ratio of the Gross enrolment ratio (%) in Pre-primary schools in 1993 to that in 1994?
Make the answer very short. 1.03. What is the ratio of the Gross enrolment ratio (%) of Primary schools in 1993 to that in 1994?
Provide a short and direct response. 1.02. What is the ratio of the Gross enrolment ratio (%) of Secondary schools in 1993 to that in 1994?
Your answer should be very brief. 0.95. What is the ratio of the Gross enrolment ratio (%) in Tertiary schools in 1993 to that in 1994?
Offer a terse response. 0.68. What is the ratio of the Gross enrolment ratio (%) in Pre-primary schools in 1993 to that in 1995?
Offer a very short reply. 0.97. What is the ratio of the Gross enrolment ratio (%) of Primary schools in 1993 to that in 1995?
Offer a terse response. 1.03. What is the ratio of the Gross enrolment ratio (%) in Secondary schools in 1993 to that in 1995?
Provide a short and direct response. 0.91. What is the ratio of the Gross enrolment ratio (%) in Tertiary schools in 1993 to that in 1995?
Offer a terse response. 0.64. What is the ratio of the Gross enrolment ratio (%) in Pre-primary schools in 1993 to that in 1996?
Your answer should be very brief. 0.98. What is the ratio of the Gross enrolment ratio (%) in Primary schools in 1993 to that in 1996?
Offer a terse response. 1.05. What is the ratio of the Gross enrolment ratio (%) of Secondary schools in 1993 to that in 1996?
Offer a very short reply. 1.01. What is the ratio of the Gross enrolment ratio (%) of Tertiary schools in 1993 to that in 1996?
Keep it short and to the point. 0.63. What is the ratio of the Gross enrolment ratio (%) of Pre-primary schools in 1993 to that in 1997?
Give a very brief answer. 1.01. What is the ratio of the Gross enrolment ratio (%) in Primary schools in 1993 to that in 1997?
Your answer should be very brief. 1.04. What is the ratio of the Gross enrolment ratio (%) in Secondary schools in 1993 to that in 1997?
Ensure brevity in your answer.  1.07. What is the ratio of the Gross enrolment ratio (%) of Tertiary schools in 1993 to that in 1997?
Offer a terse response. 0.57. What is the ratio of the Gross enrolment ratio (%) of Pre-primary schools in 1994 to that in 1995?
Provide a succinct answer. 0.95. What is the ratio of the Gross enrolment ratio (%) in Primary schools in 1994 to that in 1995?
Ensure brevity in your answer.  1.01. What is the ratio of the Gross enrolment ratio (%) in Secondary schools in 1994 to that in 1995?
Offer a very short reply. 0.96. What is the ratio of the Gross enrolment ratio (%) of Tertiary schools in 1994 to that in 1995?
Make the answer very short. 0.95. What is the ratio of the Gross enrolment ratio (%) of Pre-primary schools in 1994 to that in 1996?
Make the answer very short. 0.95. What is the ratio of the Gross enrolment ratio (%) of Primary schools in 1994 to that in 1996?
Provide a short and direct response. 1.03. What is the ratio of the Gross enrolment ratio (%) in Secondary schools in 1994 to that in 1996?
Offer a very short reply. 1.07. What is the ratio of the Gross enrolment ratio (%) in Tertiary schools in 1994 to that in 1996?
Make the answer very short. 0.93. What is the ratio of the Gross enrolment ratio (%) of Pre-primary schools in 1994 to that in 1997?
Provide a succinct answer. 0.98. What is the ratio of the Gross enrolment ratio (%) in Primary schools in 1994 to that in 1997?
Offer a terse response. 1.02. What is the ratio of the Gross enrolment ratio (%) in Secondary schools in 1994 to that in 1997?
Keep it short and to the point. 1.13. What is the ratio of the Gross enrolment ratio (%) in Tertiary schools in 1994 to that in 1997?
Provide a short and direct response. 0.83. What is the ratio of the Gross enrolment ratio (%) in Primary schools in 1995 to that in 1996?
Ensure brevity in your answer.  1.02. What is the ratio of the Gross enrolment ratio (%) in Secondary schools in 1995 to that in 1996?
Provide a succinct answer. 1.12. What is the ratio of the Gross enrolment ratio (%) of Tertiary schools in 1995 to that in 1996?
Give a very brief answer. 0.98. What is the ratio of the Gross enrolment ratio (%) in Pre-primary schools in 1995 to that in 1997?
Your answer should be compact. 1.03. What is the ratio of the Gross enrolment ratio (%) in Primary schools in 1995 to that in 1997?
Your answer should be very brief. 1.01. What is the ratio of the Gross enrolment ratio (%) in Secondary schools in 1995 to that in 1997?
Provide a succinct answer. 1.18. What is the ratio of the Gross enrolment ratio (%) of Tertiary schools in 1995 to that in 1997?
Give a very brief answer. 0.88. What is the ratio of the Gross enrolment ratio (%) of Pre-primary schools in 1996 to that in 1997?
Offer a very short reply. 1.03. What is the ratio of the Gross enrolment ratio (%) in Primary schools in 1996 to that in 1997?
Make the answer very short. 0.99. What is the ratio of the Gross enrolment ratio (%) in Secondary schools in 1996 to that in 1997?
Your answer should be very brief. 1.06. What is the ratio of the Gross enrolment ratio (%) in Tertiary schools in 1996 to that in 1997?
Keep it short and to the point. 0.89. What is the difference between the highest and the second highest Gross enrolment ratio (%) of Pre-primary schools?
Your answer should be very brief. 8.14. What is the difference between the highest and the second highest Gross enrolment ratio (%) of Primary schools?
Give a very brief answer. 3.33. What is the difference between the highest and the second highest Gross enrolment ratio (%) in Secondary schools?
Your answer should be compact. 4.46. What is the difference between the highest and the second highest Gross enrolment ratio (%) of Tertiary schools?
Offer a very short reply. 2.47. What is the difference between the highest and the lowest Gross enrolment ratio (%) of Pre-primary schools?
Provide a succinct answer. 19.17. What is the difference between the highest and the lowest Gross enrolment ratio (%) in Primary schools?
Offer a very short reply. 8.54. What is the difference between the highest and the lowest Gross enrolment ratio (%) in Secondary schools?
Give a very brief answer. 15.3. What is the difference between the highest and the lowest Gross enrolment ratio (%) of Tertiary schools?
Your answer should be compact. 10.08. 